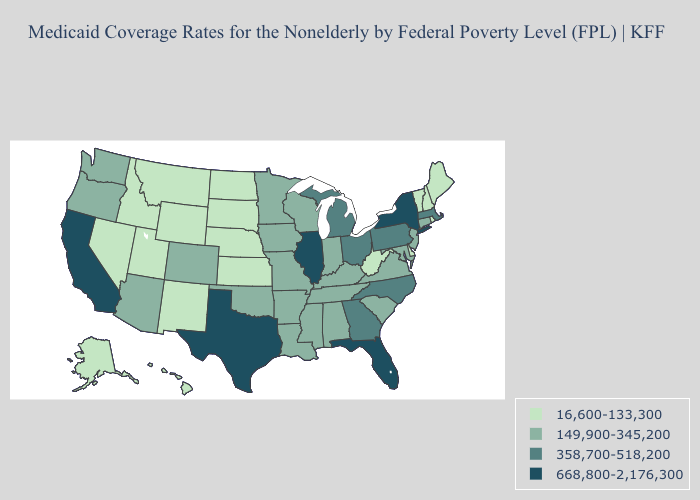Which states have the lowest value in the West?
Give a very brief answer. Alaska, Hawaii, Idaho, Montana, Nevada, New Mexico, Utah, Wyoming. What is the highest value in states that border Louisiana?
Short answer required. 668,800-2,176,300. What is the highest value in states that border Vermont?
Quick response, please. 668,800-2,176,300. Does New Mexico have a higher value than Vermont?
Short answer required. No. What is the value of Kansas?
Short answer required. 16,600-133,300. Name the states that have a value in the range 149,900-345,200?
Answer briefly. Alabama, Arizona, Arkansas, Colorado, Connecticut, Indiana, Iowa, Kentucky, Louisiana, Maryland, Minnesota, Mississippi, Missouri, New Jersey, Oklahoma, Oregon, South Carolina, Tennessee, Virginia, Washington, Wisconsin. Among the states that border Washington , which have the lowest value?
Concise answer only. Idaho. Does Pennsylvania have the same value as Missouri?
Keep it brief. No. Does Missouri have a lower value than North Carolina?
Give a very brief answer. Yes. Among the states that border Utah , does Nevada have the lowest value?
Answer briefly. Yes. What is the value of Hawaii?
Quick response, please. 16,600-133,300. Does California have the lowest value in the West?
Quick response, please. No. What is the value of Oregon?
Give a very brief answer. 149,900-345,200. Name the states that have a value in the range 668,800-2,176,300?
Be succinct. California, Florida, Illinois, New York, Texas. Name the states that have a value in the range 16,600-133,300?
Short answer required. Alaska, Delaware, Hawaii, Idaho, Kansas, Maine, Montana, Nebraska, Nevada, New Hampshire, New Mexico, North Dakota, Rhode Island, South Dakota, Utah, Vermont, West Virginia, Wyoming. 